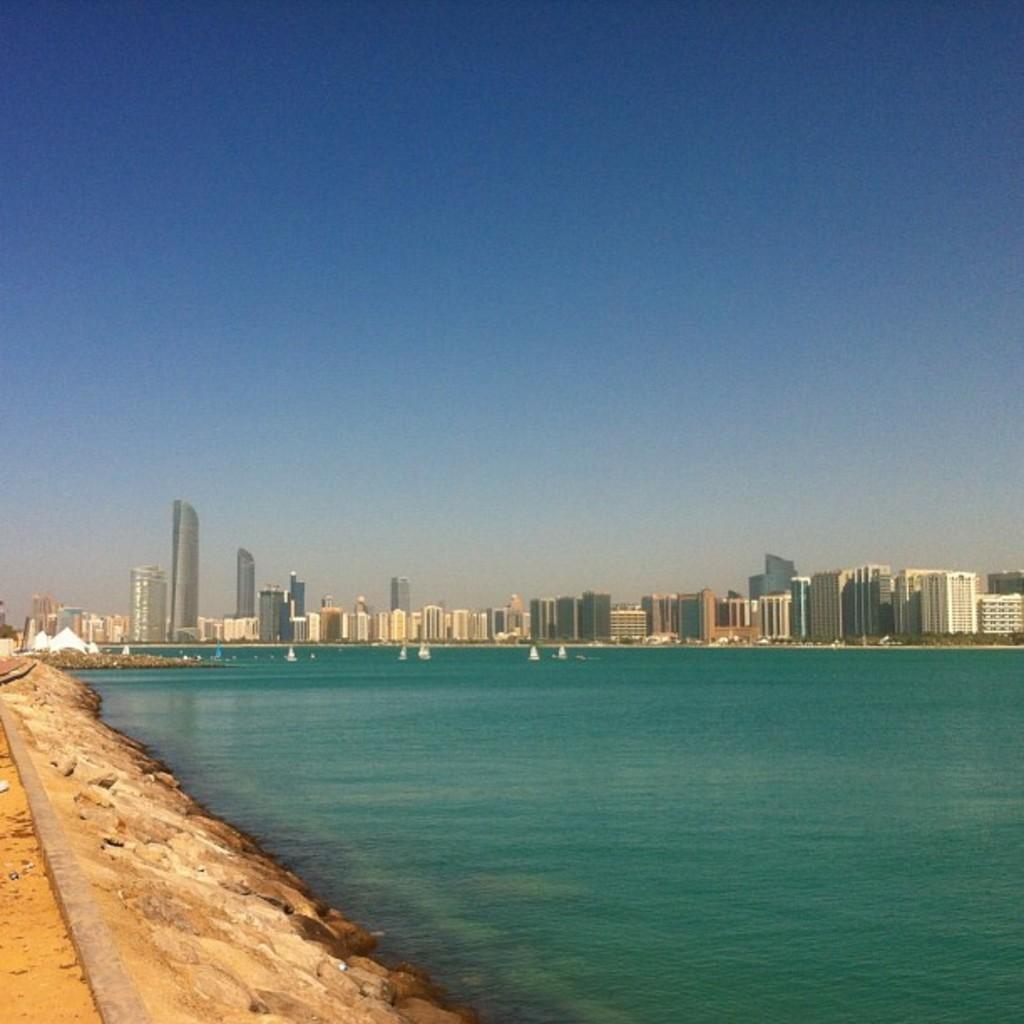In one or two sentences, can you explain what this image depicts? In the picture we can see the water surface which is blue in color and in it we can see some boats and beside it, we can see a path and in the background we can see many tower buildings and behind it we can see the sky. 